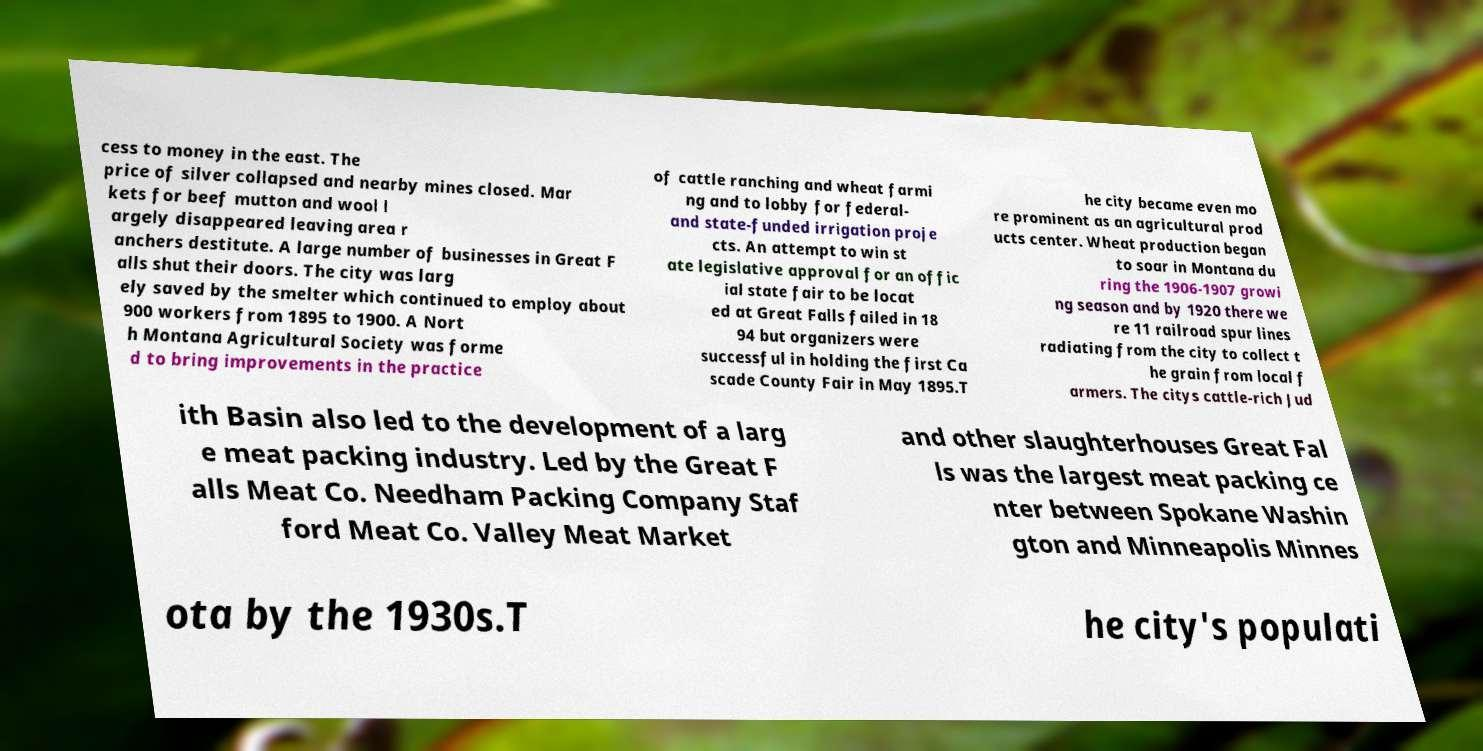I need the written content from this picture converted into text. Can you do that? cess to money in the east. The price of silver collapsed and nearby mines closed. Mar kets for beef mutton and wool l argely disappeared leaving area r anchers destitute. A large number of businesses in Great F alls shut their doors. The city was larg ely saved by the smelter which continued to employ about 900 workers from 1895 to 1900. A Nort h Montana Agricultural Society was forme d to bring improvements in the practice of cattle ranching and wheat farmi ng and to lobby for federal- and state-funded irrigation proje cts. An attempt to win st ate legislative approval for an offic ial state fair to be locat ed at Great Falls failed in 18 94 but organizers were successful in holding the first Ca scade County Fair in May 1895.T he city became even mo re prominent as an agricultural prod ucts center. Wheat production began to soar in Montana du ring the 1906-1907 growi ng season and by 1920 there we re 11 railroad spur lines radiating from the city to collect t he grain from local f armers. The citys cattle-rich Jud ith Basin also led to the development of a larg e meat packing industry. Led by the Great F alls Meat Co. Needham Packing Company Staf ford Meat Co. Valley Meat Market and other slaughterhouses Great Fal ls was the largest meat packing ce nter between Spokane Washin gton and Minneapolis Minnes ota by the 1930s.T he city's populati 